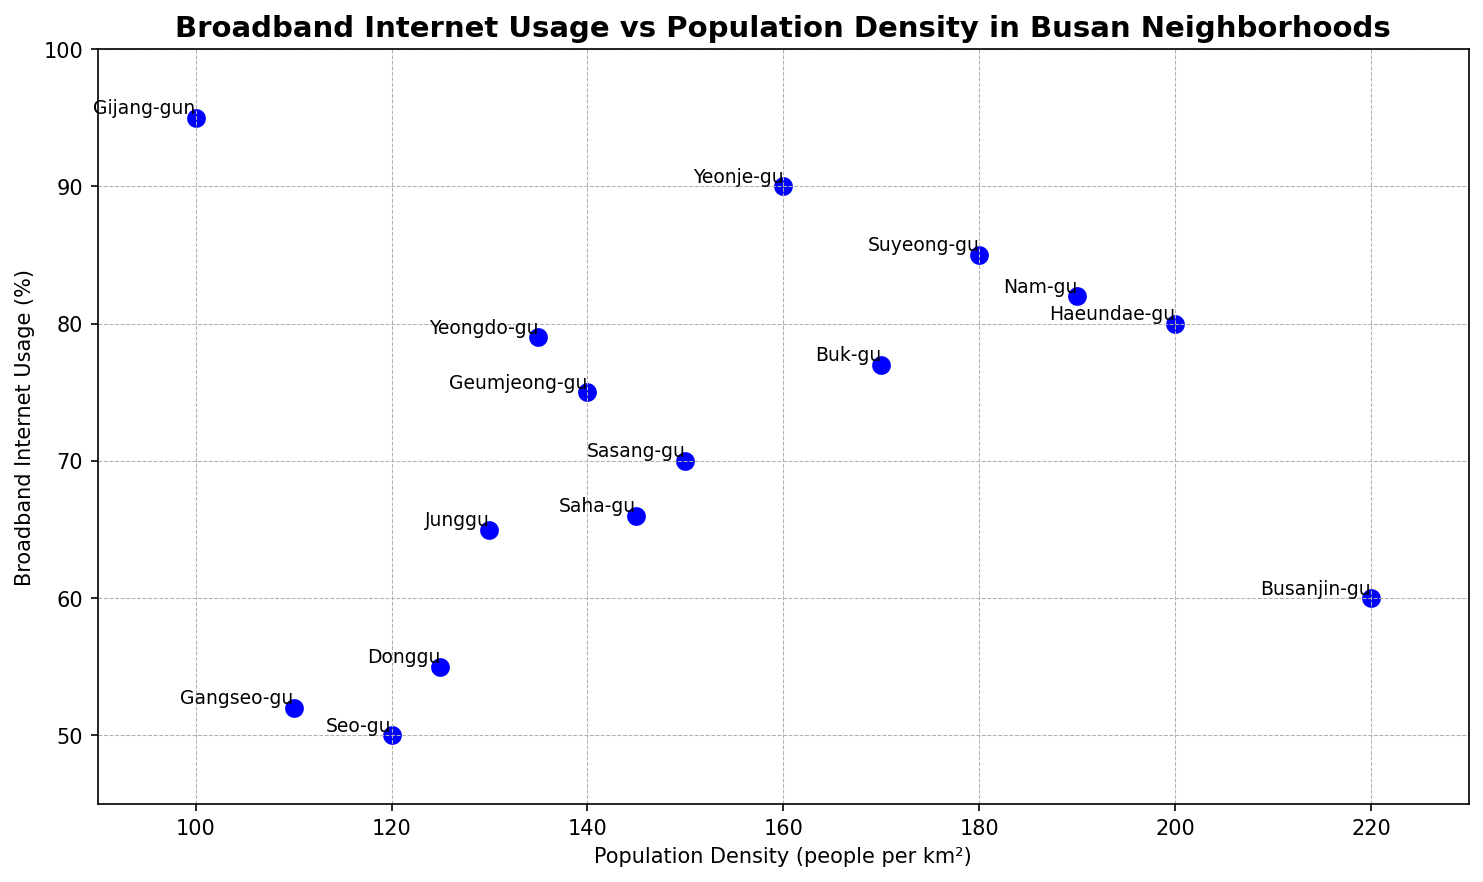Which neighborhood has the highest broadband internet usage? "Gijang-gun" has the highest broadband internet usage with 95%. This can be seen on the y-axis where the data point for "Gijang-gun" is the highest.
Answer: Gijang-gun Which neighborhood has the lowest population density? "Gijang-gun" has the lowest population density with 100 people per km². This can be seen on the x-axis where the data point for "Gijang-gun" is the farthest left.
Answer: Gijang-gun What is the relationship between broadband internet usage and population density? The scatter plot shows a mix of positive and negative values, indicating no clear linear relationship between broadband internet usage and population density. For instance, "Haeundae-gu" with high population density and "Gijang-gun" with low population density both have high internet usage.
Answer: No clear linear relationship Which neighborhoods have a broadband internet usage above 80%? The neighborhoods with broadband internet usage above 80% are "Haeundae-gu", "Suyeong-gu", "Yeonje-gu", "Nam-gu", and "Gijang-gun". This is determined by looking at data points above the 80% mark on the y-axis.
Answer: Haeundae-gu, Suyeong-gu, Yeonje-gu, Nam-gu, Gijang-gun Which neighborhood has the largest difference between broadband internet usage and population density? "Gijang-gun" has the largest absolute difference between broadband internet usage (95%) and population density (100 people per km²), giving a difference of 95 - 100 = -5 in absolute terms.
Answer: Gijang-gun How does "Busanjin-gu" compare to "Sasang-gu" in terms of broadband internet usage and population density? "Busanjin-gu" has a lower broadband internet usage (60%) compared to "Sasang-gu" (70%) and a higher population density (220 people per km²) compared to "Sasang-gu" (150 people per km²).
Answer: Busanjin-gu has lower internet usage and higher population density What is the average broadband internet usage of neighborhoods with population density above 150 people per km²? The neighborhoods with population density above 150 are "Haeundae-gu", "Suyeong-gu", "Busanjin-gu", "Nam-gu", and "Buk-gu". Their usages are 80, 85, 60, 82, and 77 respectively. Average usage = (80 + 85 + 60 + 82 + 77) / 5 = 76.8%.
Answer: 76.8% Which neighborhood is closest to the average broadband internet usage of all neighborhoods? The average broadband internet usage of all neighborhoods is (80 + 70 + 85 + 60 + 75 + 90 + 82 + 50 + 65 + 55 + 77 + 52 + 66 + 95 + 79) / 15 = 71.27%. "Yeongdo-gu" with 79% is closest to the average.
Answer: Yeongdo-gu List neighborhoods with population density between 120 and 160 people per km². The neighborhoods with population density between 120 and 160 people per km² are "Sasang-gu" (150), "Geumjeong-gu" (140), "Yeonje-gu" (160), "Seo-gu" (120), "Junggu" (130), "Donggu" (125), "Saha-gu" (145), and "Yeongdo-gu" (135).
Answer: Sasang-gu, Geumjeong-gu, Yeonje-gu, Seo-gu, Junggu, Donggu, Saha-gu, Yeongdo-gu 